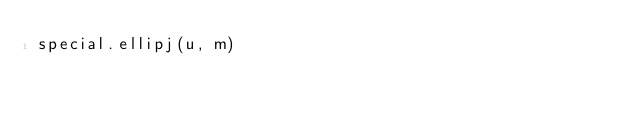<code> <loc_0><loc_0><loc_500><loc_500><_Python_>special.ellipj(u, m)</code> 